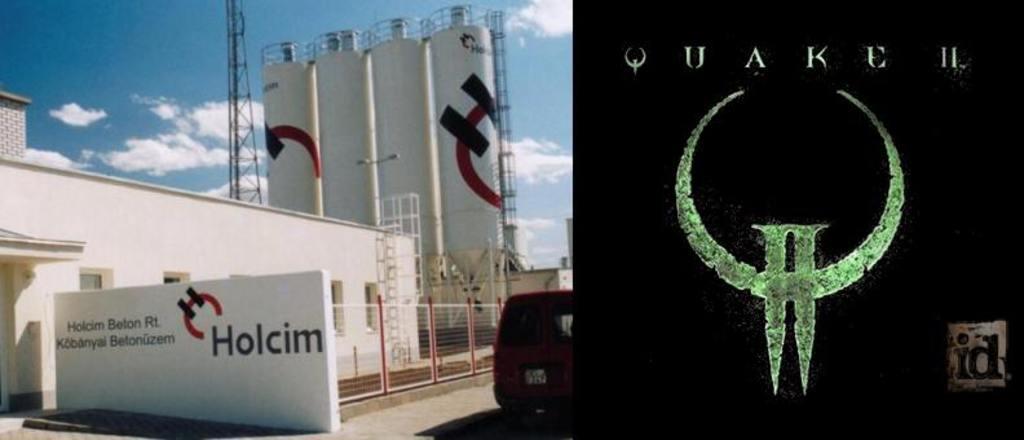How would you summarize this image in a sentence or two? It is an industry there is a building and behind building there are four tall towers and there is a vehicle in front of the building and in the background there is a sky. 